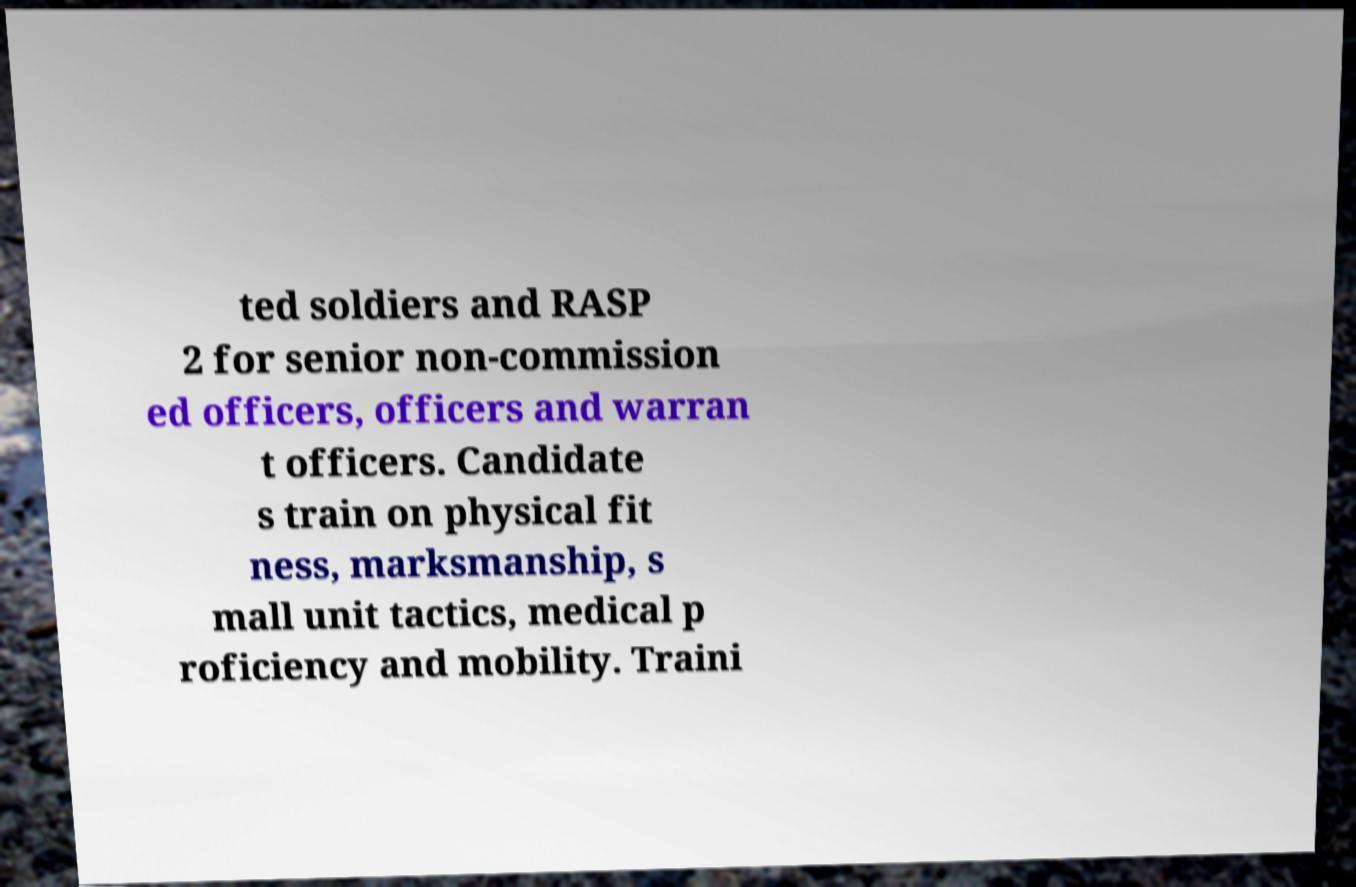Could you extract and type out the text from this image? ted soldiers and RASP 2 for senior non-commission ed officers, officers and warran t officers. Candidate s train on physical fit ness, marksmanship, s mall unit tactics, medical p roficiency and mobility. Traini 